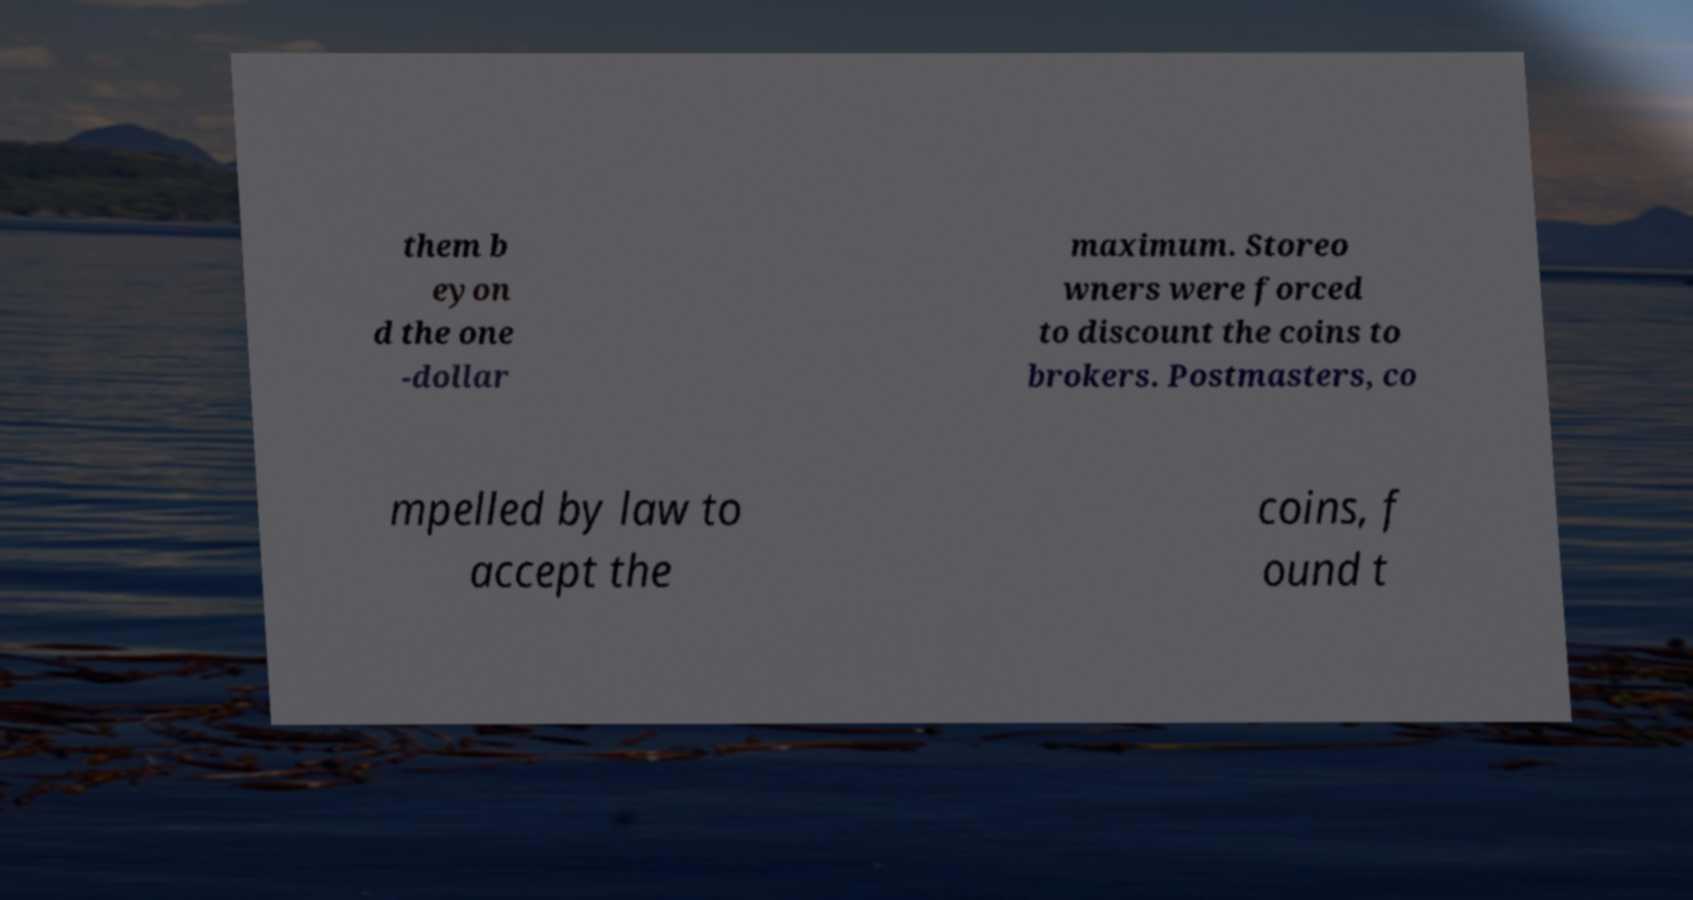There's text embedded in this image that I need extracted. Can you transcribe it verbatim? them b eyon d the one -dollar maximum. Storeo wners were forced to discount the coins to brokers. Postmasters, co mpelled by law to accept the coins, f ound t 